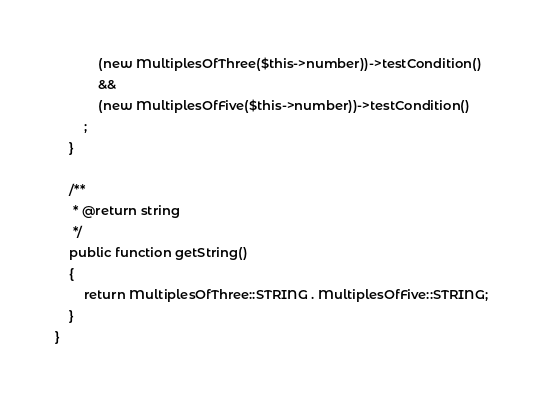<code> <loc_0><loc_0><loc_500><loc_500><_PHP_>            (new MultiplesOfThree($this->number))->testCondition()
            &&
            (new MultiplesOfFive($this->number))->testCondition()
        ;
    }

    /**
     * @return string
     */
    public function getString()
    {
        return MultiplesOfThree::STRING . MultiplesOfFive::STRING;
    }
}</code> 